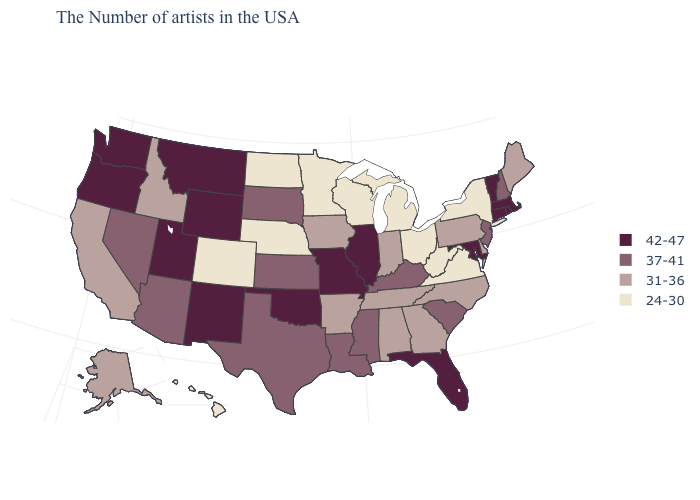What is the highest value in the West ?
Answer briefly. 42-47. Is the legend a continuous bar?
Give a very brief answer. No. Does California have the same value as North Carolina?
Concise answer only. Yes. Does Illinois have the same value as Hawaii?
Quick response, please. No. Among the states that border Ohio , does West Virginia have the lowest value?
Answer briefly. Yes. Name the states that have a value in the range 42-47?
Quick response, please. Massachusetts, Rhode Island, Vermont, Connecticut, Maryland, Florida, Illinois, Missouri, Oklahoma, Wyoming, New Mexico, Utah, Montana, Washington, Oregon. What is the value of Alaska?
Short answer required. 31-36. What is the lowest value in states that border Iowa?
Be succinct. 24-30. Does Minnesota have a lower value than Ohio?
Concise answer only. No. What is the lowest value in the USA?
Keep it brief. 24-30. Which states have the highest value in the USA?
Short answer required. Massachusetts, Rhode Island, Vermont, Connecticut, Maryland, Florida, Illinois, Missouri, Oklahoma, Wyoming, New Mexico, Utah, Montana, Washington, Oregon. Name the states that have a value in the range 31-36?
Give a very brief answer. Maine, Delaware, Pennsylvania, North Carolina, Georgia, Indiana, Alabama, Tennessee, Arkansas, Iowa, Idaho, California, Alaska. Does the map have missing data?
Answer briefly. No. How many symbols are there in the legend?
Quick response, please. 4. How many symbols are there in the legend?
Be succinct. 4. 